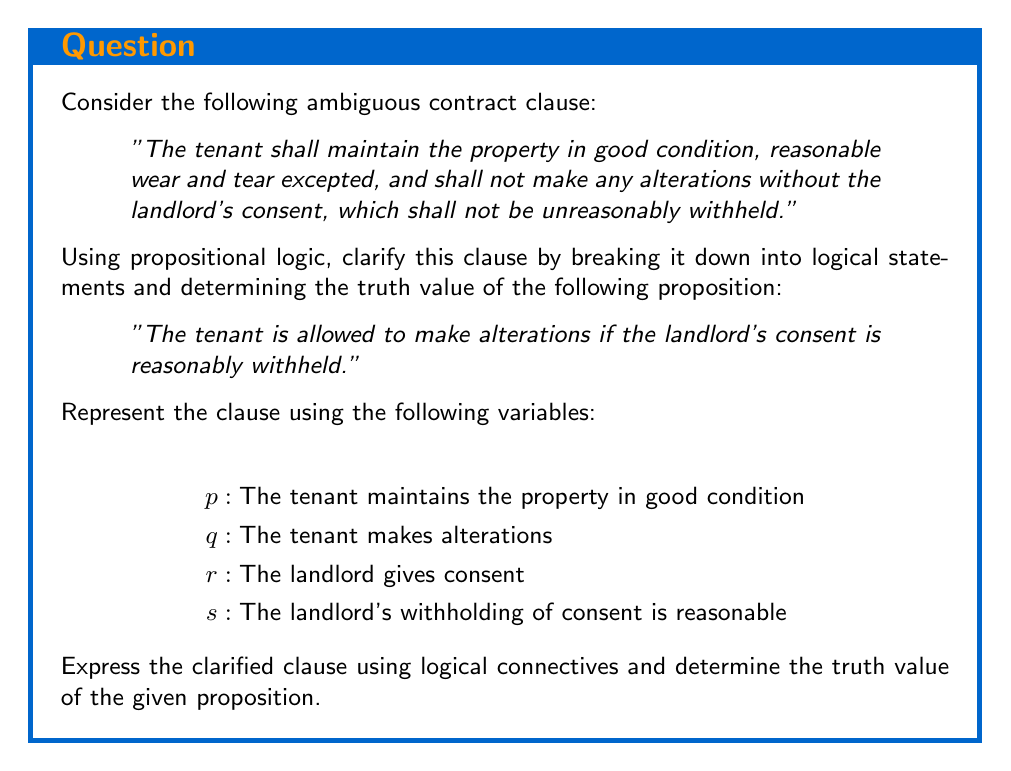Provide a solution to this math problem. Let's break down the clause and represent it using propositional logic:

1. The tenant's obligations:
   $p \land (\neg q \lor r)$

2. The landlord's constraint:
   $r \lor \neg s$

The complete logical representation of the clause is:
$$(p \land (\neg q \lor r)) \land (r \lor \neg s)$$

Now, let's analyze the given proposition:
"The tenant is allowed to make alterations if the landlord's consent is reasonably withheld."

This can be represented as: $(\neg r \land s) \rightarrow q$

To determine if this proposition is true according to the contract clause, we need to check if it's compatible with the logical representation we derived.

Step 1: Assume the antecedent is true: $\neg r \land s$

Step 2: From the clause representation, we know that $r \lor \neg s$ must be true.
        Substituting $\neg r$ and $s$ from Step 1, we get:
        $(\neg r \lor \neg s) \land (r \lor \neg s)$
        This simplifies to $\neg s$, which contradicts our assumption of $s$ being true.

Step 3: This contradiction shows that the situation described in the antecedent ($\neg r \land s$) is not possible under the contract clause.

Step 4: In propositional logic, any implication with a false antecedent is considered vacuously true. Therefore, the given proposition is true, but it's important to note that the situation it describes cannot occur under the terms of the contract.
Answer: True (vacuously) 